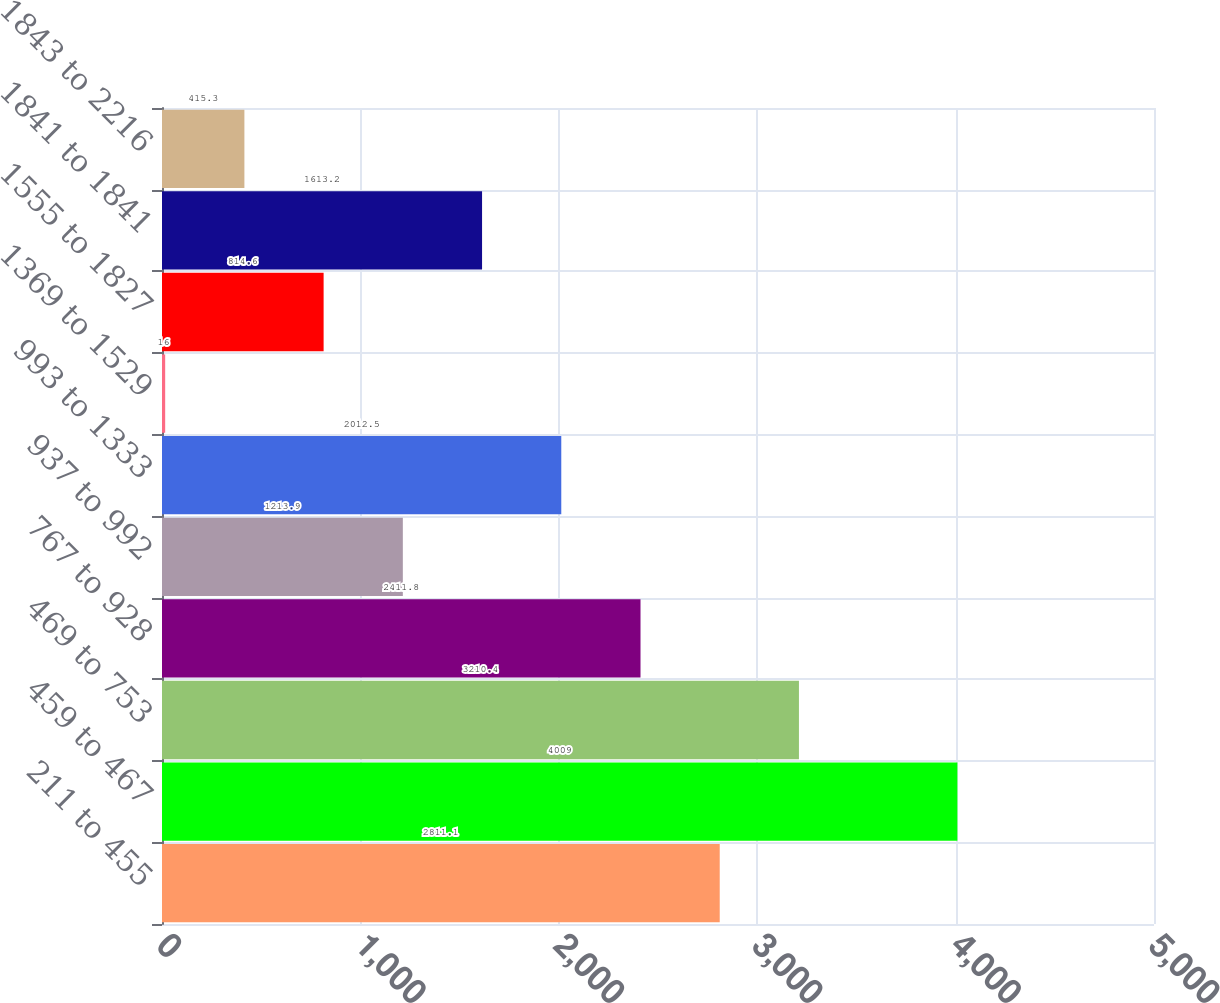Convert chart. <chart><loc_0><loc_0><loc_500><loc_500><bar_chart><fcel>211 to 455<fcel>459 to 467<fcel>469 to 753<fcel>767 to 928<fcel>937 to 992<fcel>993 to 1333<fcel>1369 to 1529<fcel>1555 to 1827<fcel>1841 to 1841<fcel>1843 to 2216<nl><fcel>2811.1<fcel>4009<fcel>3210.4<fcel>2411.8<fcel>1213.9<fcel>2012.5<fcel>16<fcel>814.6<fcel>1613.2<fcel>415.3<nl></chart> 